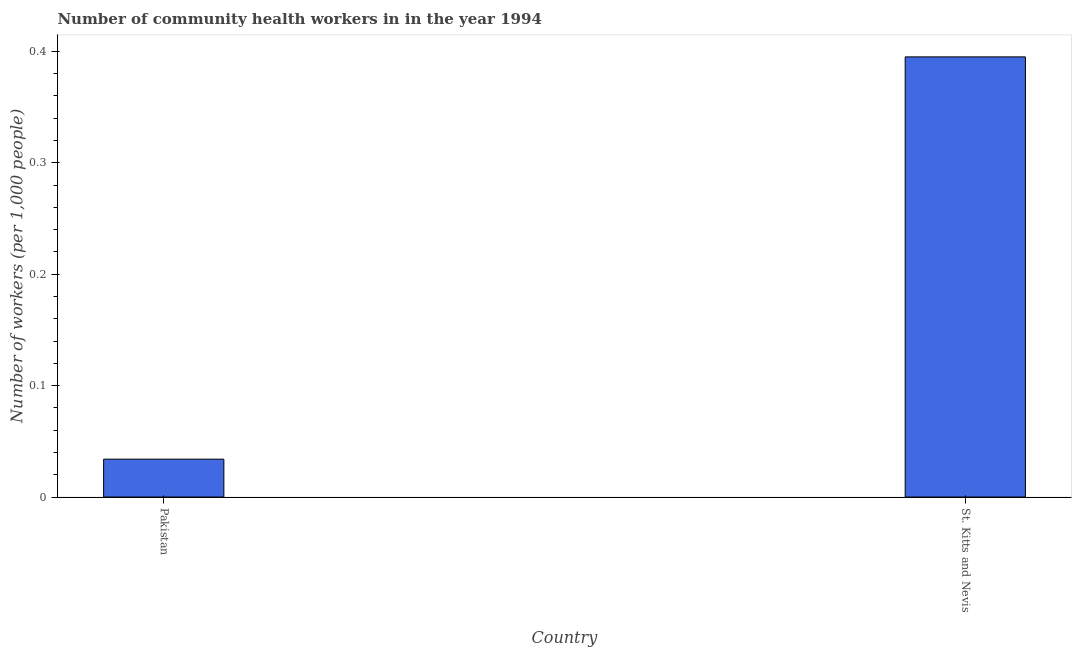Does the graph contain any zero values?
Provide a short and direct response. No. What is the title of the graph?
Ensure brevity in your answer.  Number of community health workers in in the year 1994. What is the label or title of the Y-axis?
Offer a terse response. Number of workers (per 1,0 people). What is the number of community health workers in St. Kitts and Nevis?
Offer a very short reply. 0.4. Across all countries, what is the maximum number of community health workers?
Your response must be concise. 0.4. Across all countries, what is the minimum number of community health workers?
Your answer should be very brief. 0.03. In which country was the number of community health workers maximum?
Your answer should be very brief. St. Kitts and Nevis. In which country was the number of community health workers minimum?
Offer a terse response. Pakistan. What is the sum of the number of community health workers?
Provide a succinct answer. 0.43. What is the difference between the number of community health workers in Pakistan and St. Kitts and Nevis?
Your response must be concise. -0.36. What is the average number of community health workers per country?
Provide a succinct answer. 0.21. What is the median number of community health workers?
Your answer should be very brief. 0.21. In how many countries, is the number of community health workers greater than 0.32 ?
Offer a terse response. 1. What is the ratio of the number of community health workers in Pakistan to that in St. Kitts and Nevis?
Your answer should be compact. 0.09. In how many countries, is the number of community health workers greater than the average number of community health workers taken over all countries?
Your answer should be very brief. 1. How many bars are there?
Your answer should be very brief. 2. Are all the bars in the graph horizontal?
Your answer should be very brief. No. What is the Number of workers (per 1,000 people) of Pakistan?
Keep it short and to the point. 0.03. What is the Number of workers (per 1,000 people) of St. Kitts and Nevis?
Your answer should be compact. 0.4. What is the difference between the Number of workers (per 1,000 people) in Pakistan and St. Kitts and Nevis?
Your response must be concise. -0.36. What is the ratio of the Number of workers (per 1,000 people) in Pakistan to that in St. Kitts and Nevis?
Your response must be concise. 0.09. 